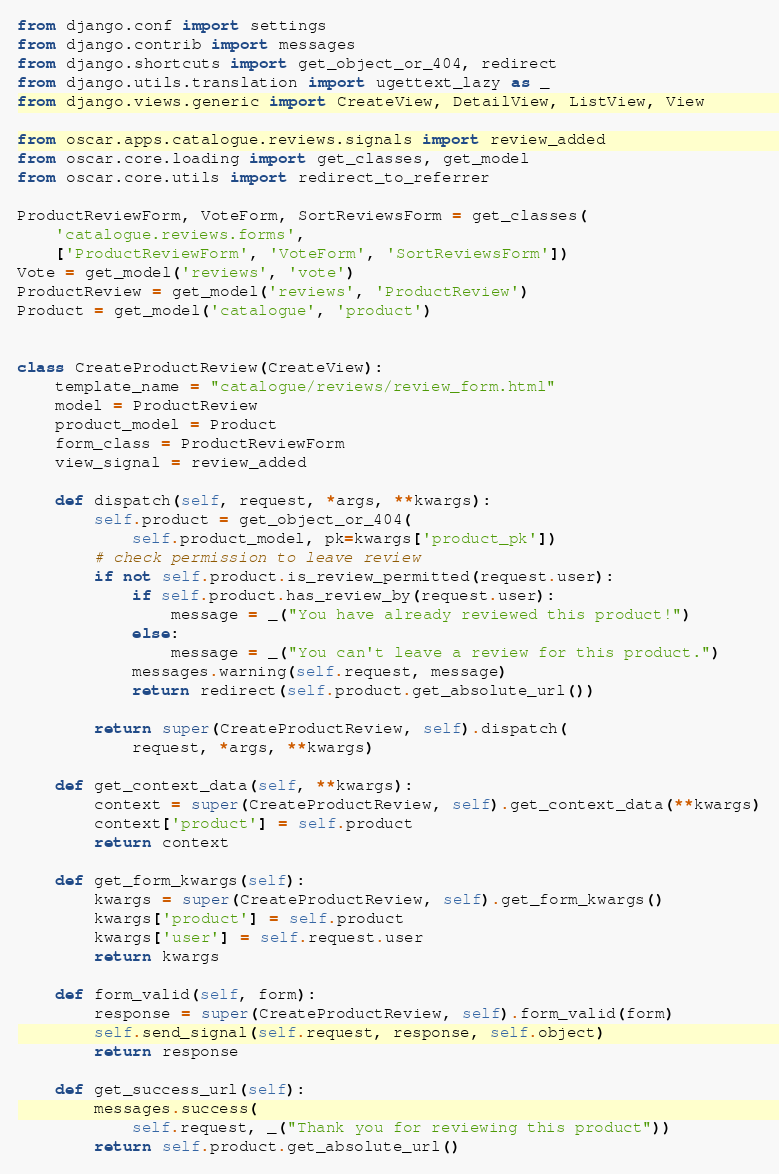Convert code to text. <code><loc_0><loc_0><loc_500><loc_500><_Python_>from django.conf import settings
from django.contrib import messages
from django.shortcuts import get_object_or_404, redirect
from django.utils.translation import ugettext_lazy as _
from django.views.generic import CreateView, DetailView, ListView, View

from oscar.apps.catalogue.reviews.signals import review_added
from oscar.core.loading import get_classes, get_model
from oscar.core.utils import redirect_to_referrer

ProductReviewForm, VoteForm, SortReviewsForm = get_classes(
    'catalogue.reviews.forms',
    ['ProductReviewForm', 'VoteForm', 'SortReviewsForm'])
Vote = get_model('reviews', 'vote')
ProductReview = get_model('reviews', 'ProductReview')
Product = get_model('catalogue', 'product')


class CreateProductReview(CreateView):
    template_name = "catalogue/reviews/review_form.html"
    model = ProductReview
    product_model = Product
    form_class = ProductReviewForm
    view_signal = review_added

    def dispatch(self, request, *args, **kwargs):
        self.product = get_object_or_404(
            self.product_model, pk=kwargs['product_pk'])
        # check permission to leave review
        if not self.product.is_review_permitted(request.user):
            if self.product.has_review_by(request.user):
                message = _("You have already reviewed this product!")
            else:
                message = _("You can't leave a review for this product.")
            messages.warning(self.request, message)
            return redirect(self.product.get_absolute_url())

        return super(CreateProductReview, self).dispatch(
            request, *args, **kwargs)

    def get_context_data(self, **kwargs):
        context = super(CreateProductReview, self).get_context_data(**kwargs)
        context['product'] = self.product
        return context

    def get_form_kwargs(self):
        kwargs = super(CreateProductReview, self).get_form_kwargs()
        kwargs['product'] = self.product
        kwargs['user'] = self.request.user
        return kwargs

    def form_valid(self, form):
        response = super(CreateProductReview, self).form_valid(form)
        self.send_signal(self.request, response, self.object)
        return response

    def get_success_url(self):
        messages.success(
            self.request, _("Thank you for reviewing this product"))
        return self.product.get_absolute_url()
</code> 